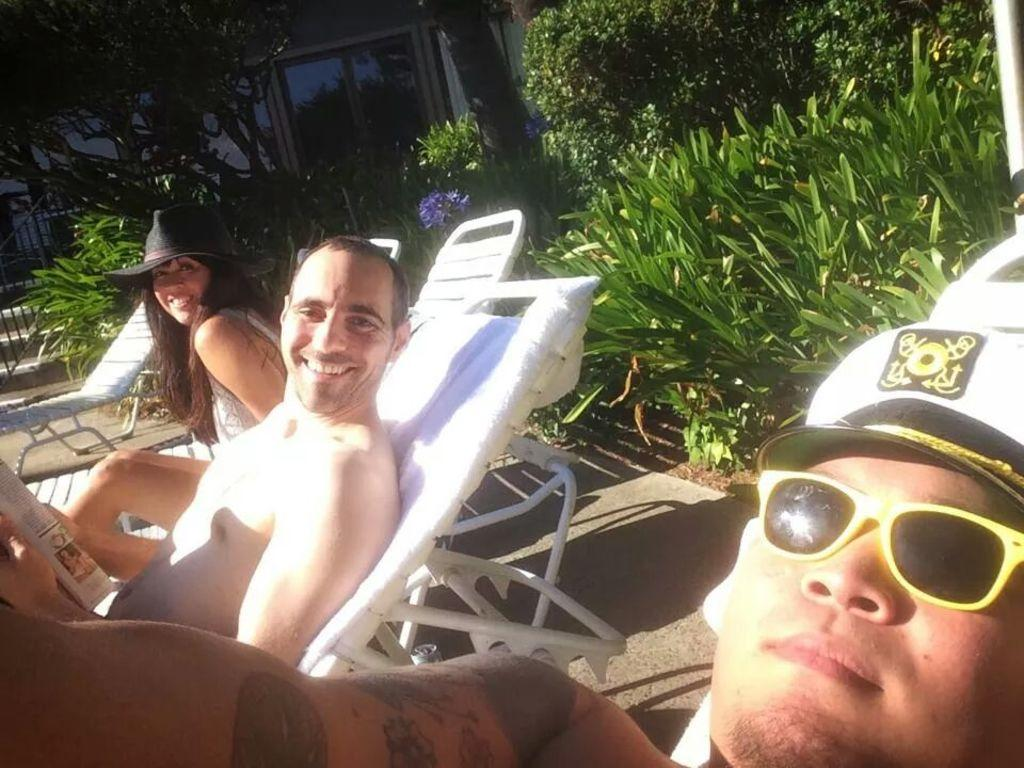How many people are in the image? There are three people in the image. What is the facial expression of the people in the image? Two of the people are smiling. What are the people sitting on in the image? The people are sitting on chairs. What type of headwear is visible in the image? There are caps visible in the image. What type of protective eyewear is visible in the image? There are goggles visible in the image. What is the natural element present in the image? There are trees in the image. What type of barrier is present in the image? There is a fence in the image. What architectural feature can be seen in the background of the image? There are glass doors in the background of the image. What type of coat is the man wearing in the alley in the image? There is no man wearing a coat in an alley present in the image. 